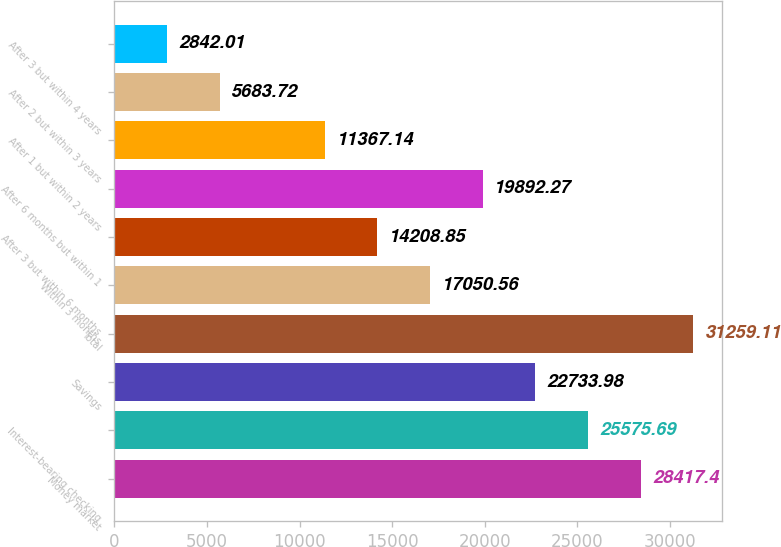Convert chart to OTSL. <chart><loc_0><loc_0><loc_500><loc_500><bar_chart><fcel>Money market<fcel>Interest-bearing checking<fcel>Savings<fcel>Total<fcel>Within 3 months<fcel>After 3 but within 6 months<fcel>After 6 months but within 1<fcel>After 1 but within 2 years<fcel>After 2 but within 3 years<fcel>After 3 but within 4 years<nl><fcel>28417.4<fcel>25575.7<fcel>22734<fcel>31259.1<fcel>17050.6<fcel>14208.9<fcel>19892.3<fcel>11367.1<fcel>5683.72<fcel>2842.01<nl></chart> 